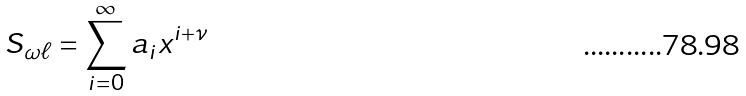Convert formula to latex. <formula><loc_0><loc_0><loc_500><loc_500>S _ { \omega \ell } = \sum _ { i = 0 } ^ { \infty } a _ { i } x ^ { i + \nu }</formula> 